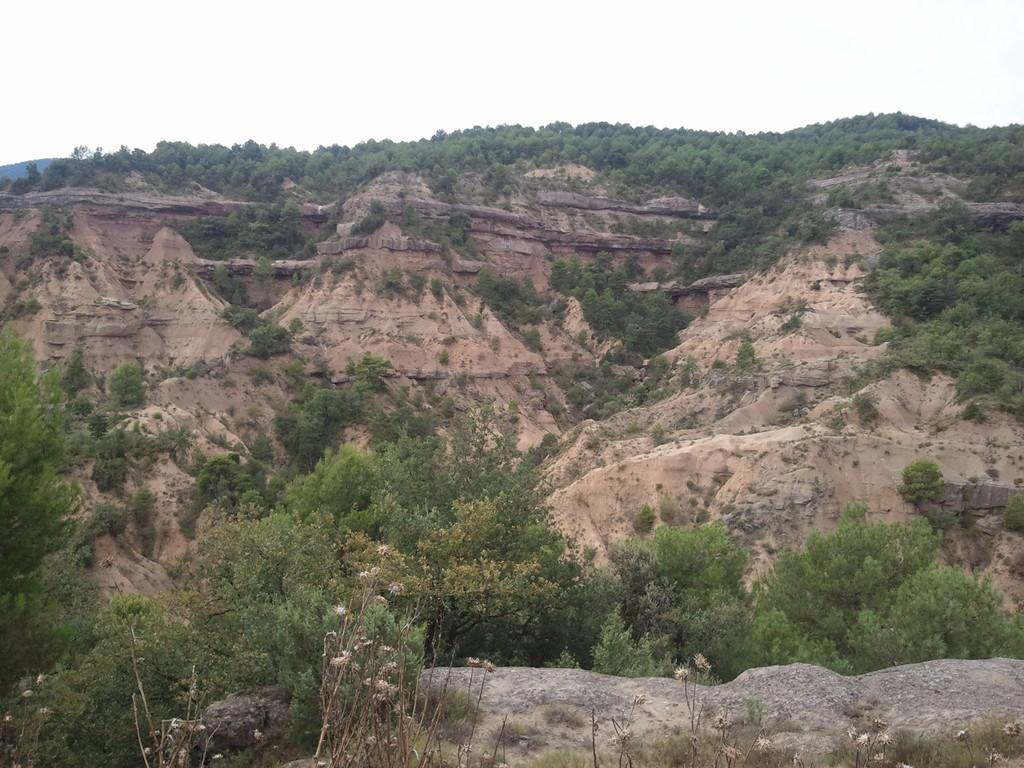What type of landscape is depicted in the image? The image features hills. What other natural elements can be seen in the image? There are rocks and trees visible in the image. How many cherries are hanging from the trees in the image? There are no cherries visible in the image; it only features rocks, trees, and hills. 